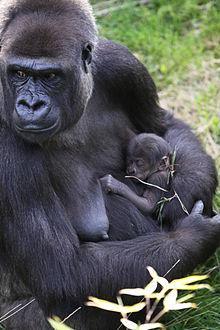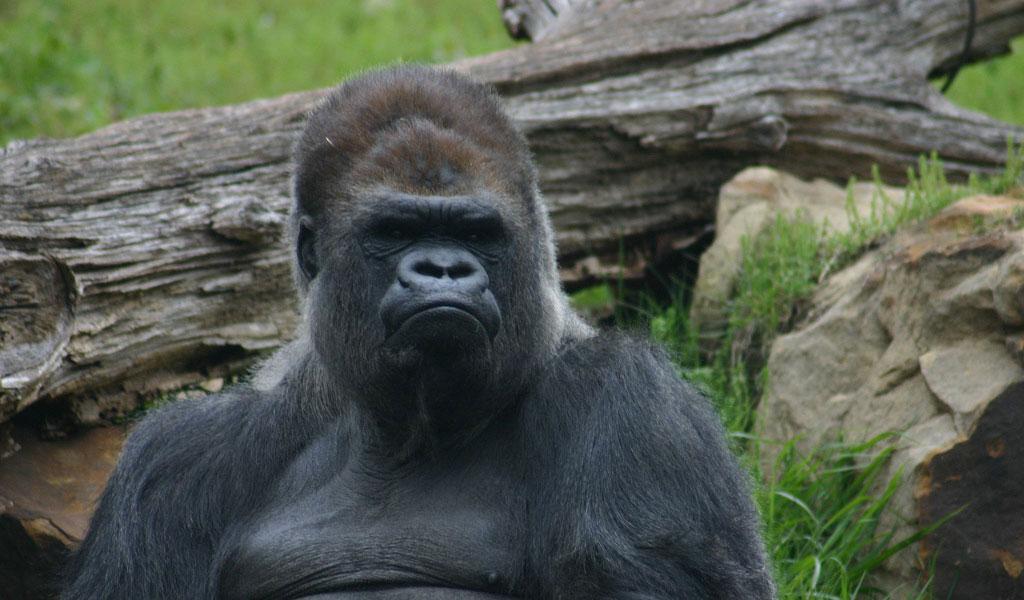The first image is the image on the left, the second image is the image on the right. For the images shown, is this caption "There is one gorilla walking and one that is stationary while facing to the left." true? Answer yes or no. No. The first image is the image on the left, the second image is the image on the right. Considering the images on both sides, is "There are no more than two gorillas." valid? Answer yes or no. No. 